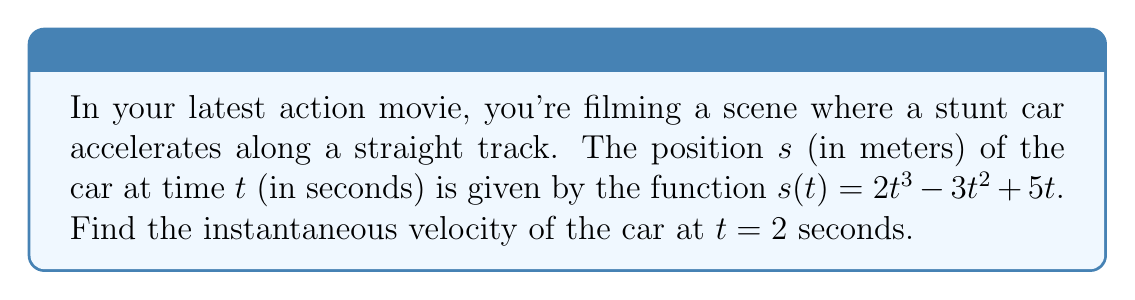Solve this math problem. To find the instantaneous velocity, we need to calculate the derivative of the position function and evaluate it at $t = 2$ seconds.

Step 1: Find the derivative of $s(t)$.
The velocity function $v(t)$ is the derivative of the position function $s(t)$.

$$v(t) = \frac{d}{dt}[s(t)] = \frac{d}{dt}[2t^3 - 3t^2 + 5t]$$

Using the power rule and linearity of derivatives:

$$v(t) = 6t^2 - 6t + 5$$

Step 2: Evaluate $v(t)$ at $t = 2$ seconds.

$$v(2) = 6(2)^2 - 6(2) + 5$$
$$v(2) = 6(4) - 12 + 5$$
$$v(2) = 24 - 12 + 5$$
$$v(2) = 17$$

Therefore, the instantaneous velocity of the stunt car at $t = 2$ seconds is 17 m/s.
Answer: 17 m/s 